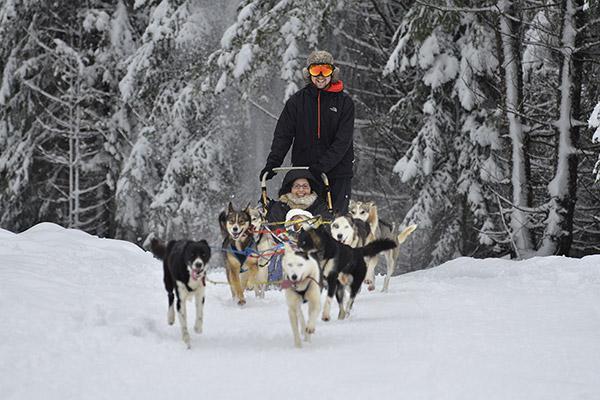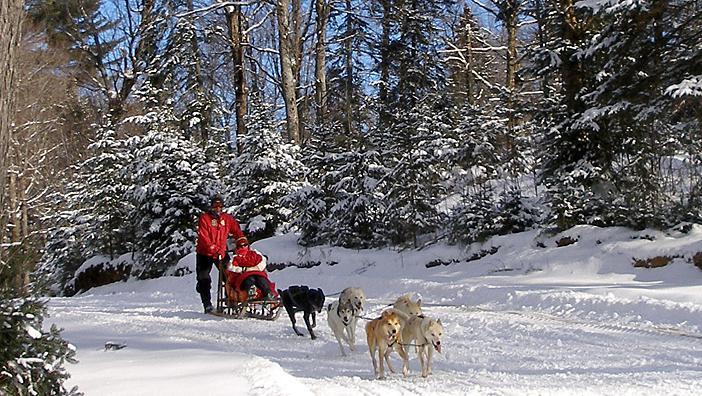The first image is the image on the left, the second image is the image on the right. For the images shown, is this caption "One image shows one dog sled team being led by a man in a red jacket." true? Answer yes or no. Yes. The first image is the image on the left, the second image is the image on the right. For the images displayed, is the sentence "The right image has a man on a sled with a red jacket" factually correct? Answer yes or no. Yes. 